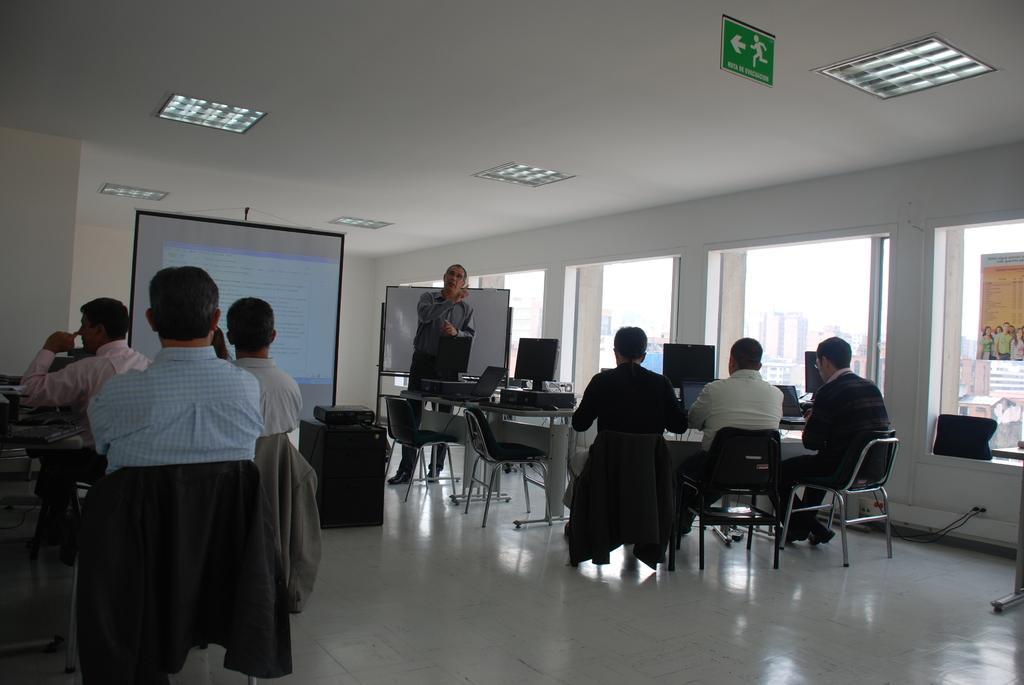In one or two sentences, can you explain what this image depicts? This picture shows a group of people seated on the chairs and we see monitors and a man speaking and we see a projector screen and a white board on the right and we see a sign board 